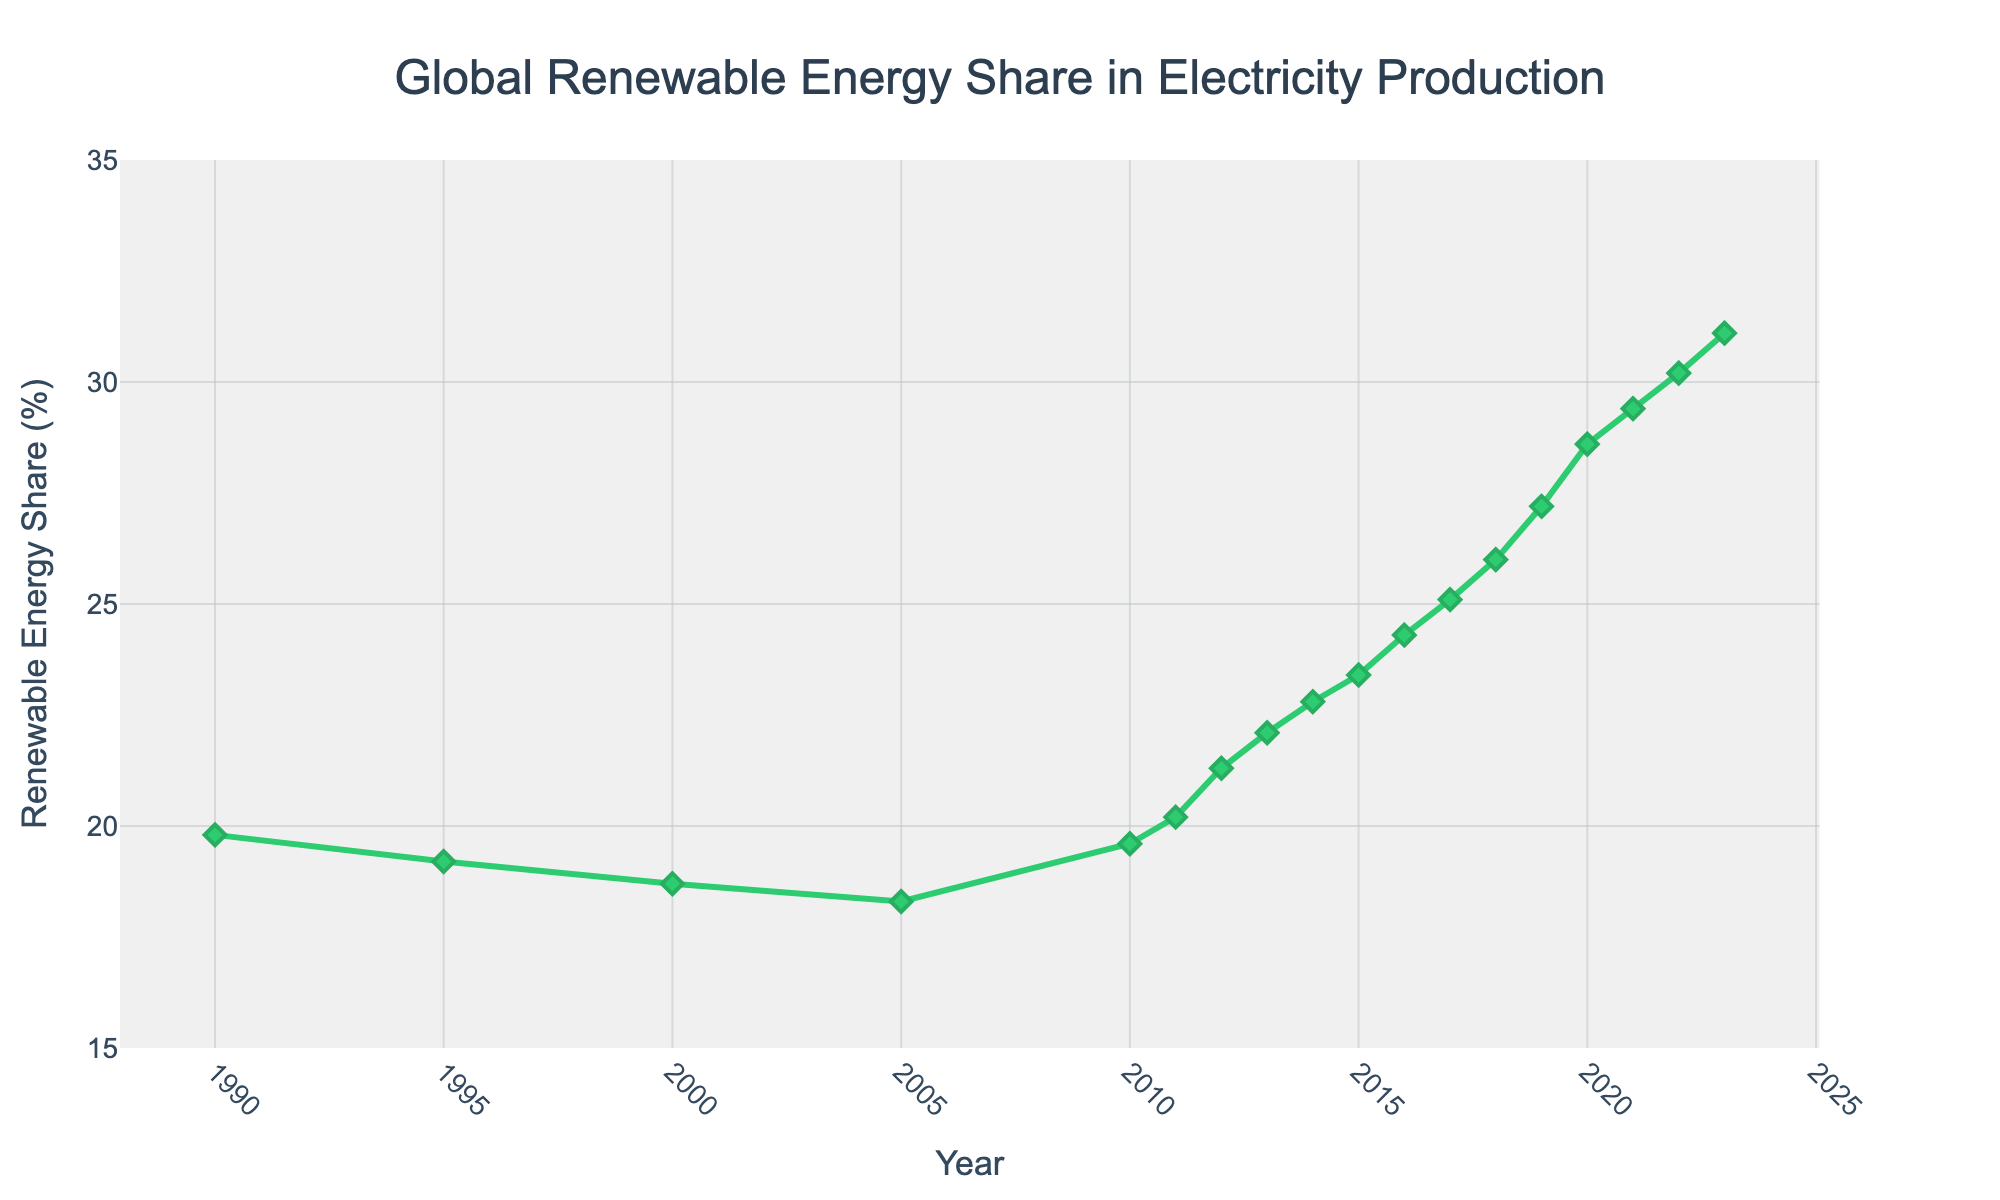What was the renewable energy share in 2005? Look at the graph and find the value corresponding to the year 2005. The green line with markers indicates values for renewable energy shares.
Answer: 18.3% In which year did the renewable energy share first exceed 25%? To determine the first instance where the share exceeds 25%, find the earliest point on the graph where the green line rises above the 25% mark.
Answer: 2017 What is the difference in renewable energy share between 1990 and 2023? Subtract the value in 1990 from the value in 2023: 31.1% - 19.8%.
Answer: 11.3% Between which consecutive years was the largest increase in renewable energy share observed? Look for the steepest slope in the green line between two consecutive years. The largest difference can be seen between 2019 and 2020.
Answer: 2019 to 2020 What was the average renewable energy share for the years 2010 to 2015? Calculate the average by summing the values from 2010 to 2015 and dividing by the number of years: (19.6 + 20.2 + 21.3 + 22.1 + 22.8 + 23.4) / 6.
Answer: 21.57% How many years was the renewable energy share above 20%? Count the number of years where the line indicating renewable energy share is above the 20% mark from the graph. From 2011 onwards, the share is above 20%.
Answer: 13 years Did the renewable energy share ever decrease between two consecutive years? If so, which years experienced this decrease? Check the graph to see if the line ever drops between two consecutive points. This happened between 1990 and 2005.
Answer: 1990 to 2005 By how much did the renewable energy share change from 2018 to 2023? Subtract the value in 2018 from the value in 2023: 31.1% - 26.0%.
Answer: 5.1% Which year had the smallest renewable energy share according to the graph? Find the lowest point on the green line in the chart. The smallest share is seen in the year 2005.
Answer: 2005 